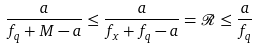Convert formula to latex. <formula><loc_0><loc_0><loc_500><loc_500>\frac { a } { f _ { q } + M - a } \leq \frac { a } { f _ { x } + f _ { q } - a } = \mathcal { R } \leq \frac { a } { f _ { q } }</formula> 